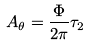<formula> <loc_0><loc_0><loc_500><loc_500>A _ { \theta } = \frac { \Phi } { 2 \pi } \tau _ { 2 }</formula> 